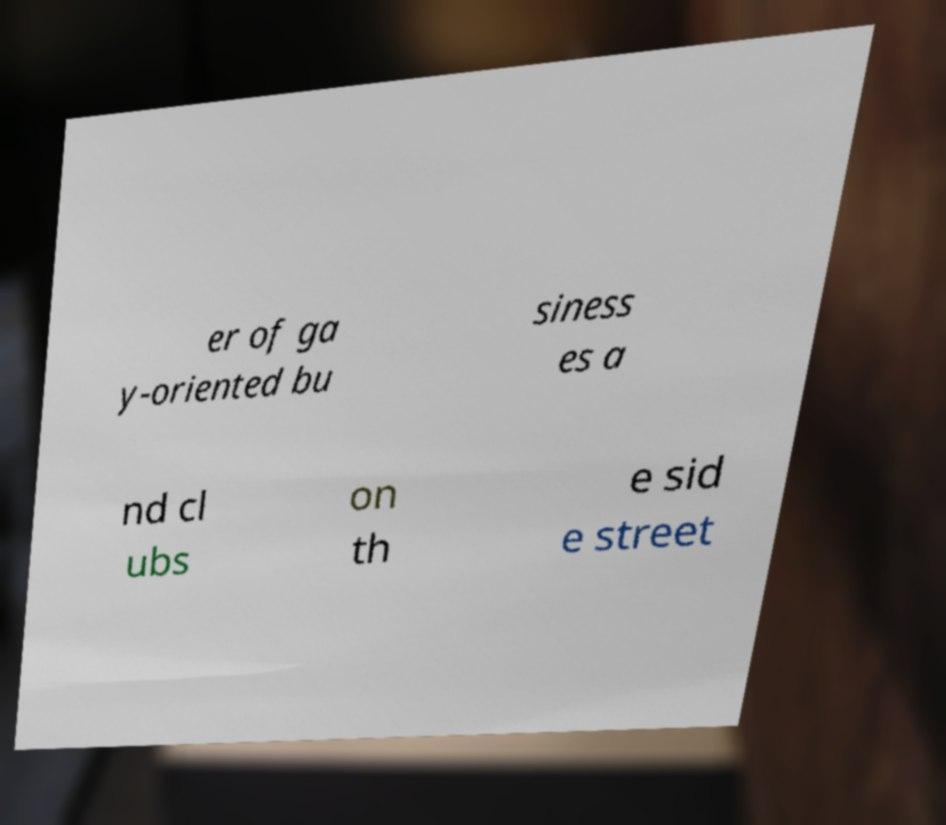Can you accurately transcribe the text from the provided image for me? er of ga y-oriented bu siness es a nd cl ubs on th e sid e street 